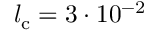<formula> <loc_0><loc_0><loc_500><loc_500>l _ { c } = 3 \cdot 1 0 ^ { - 2 }</formula> 